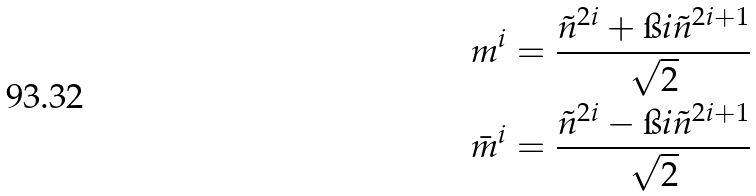Convert formula to latex. <formula><loc_0><loc_0><loc_500><loc_500>m ^ { i } & = \frac { \tilde { n } ^ { 2 i } + \i i \tilde { n } ^ { 2 i + 1 } } { \sqrt { 2 } } \\ \bar { m } ^ { i } & = \frac { \tilde { n } ^ { 2 i } - \i i \tilde { n } ^ { 2 i + 1 } } { \sqrt { 2 } }</formula> 